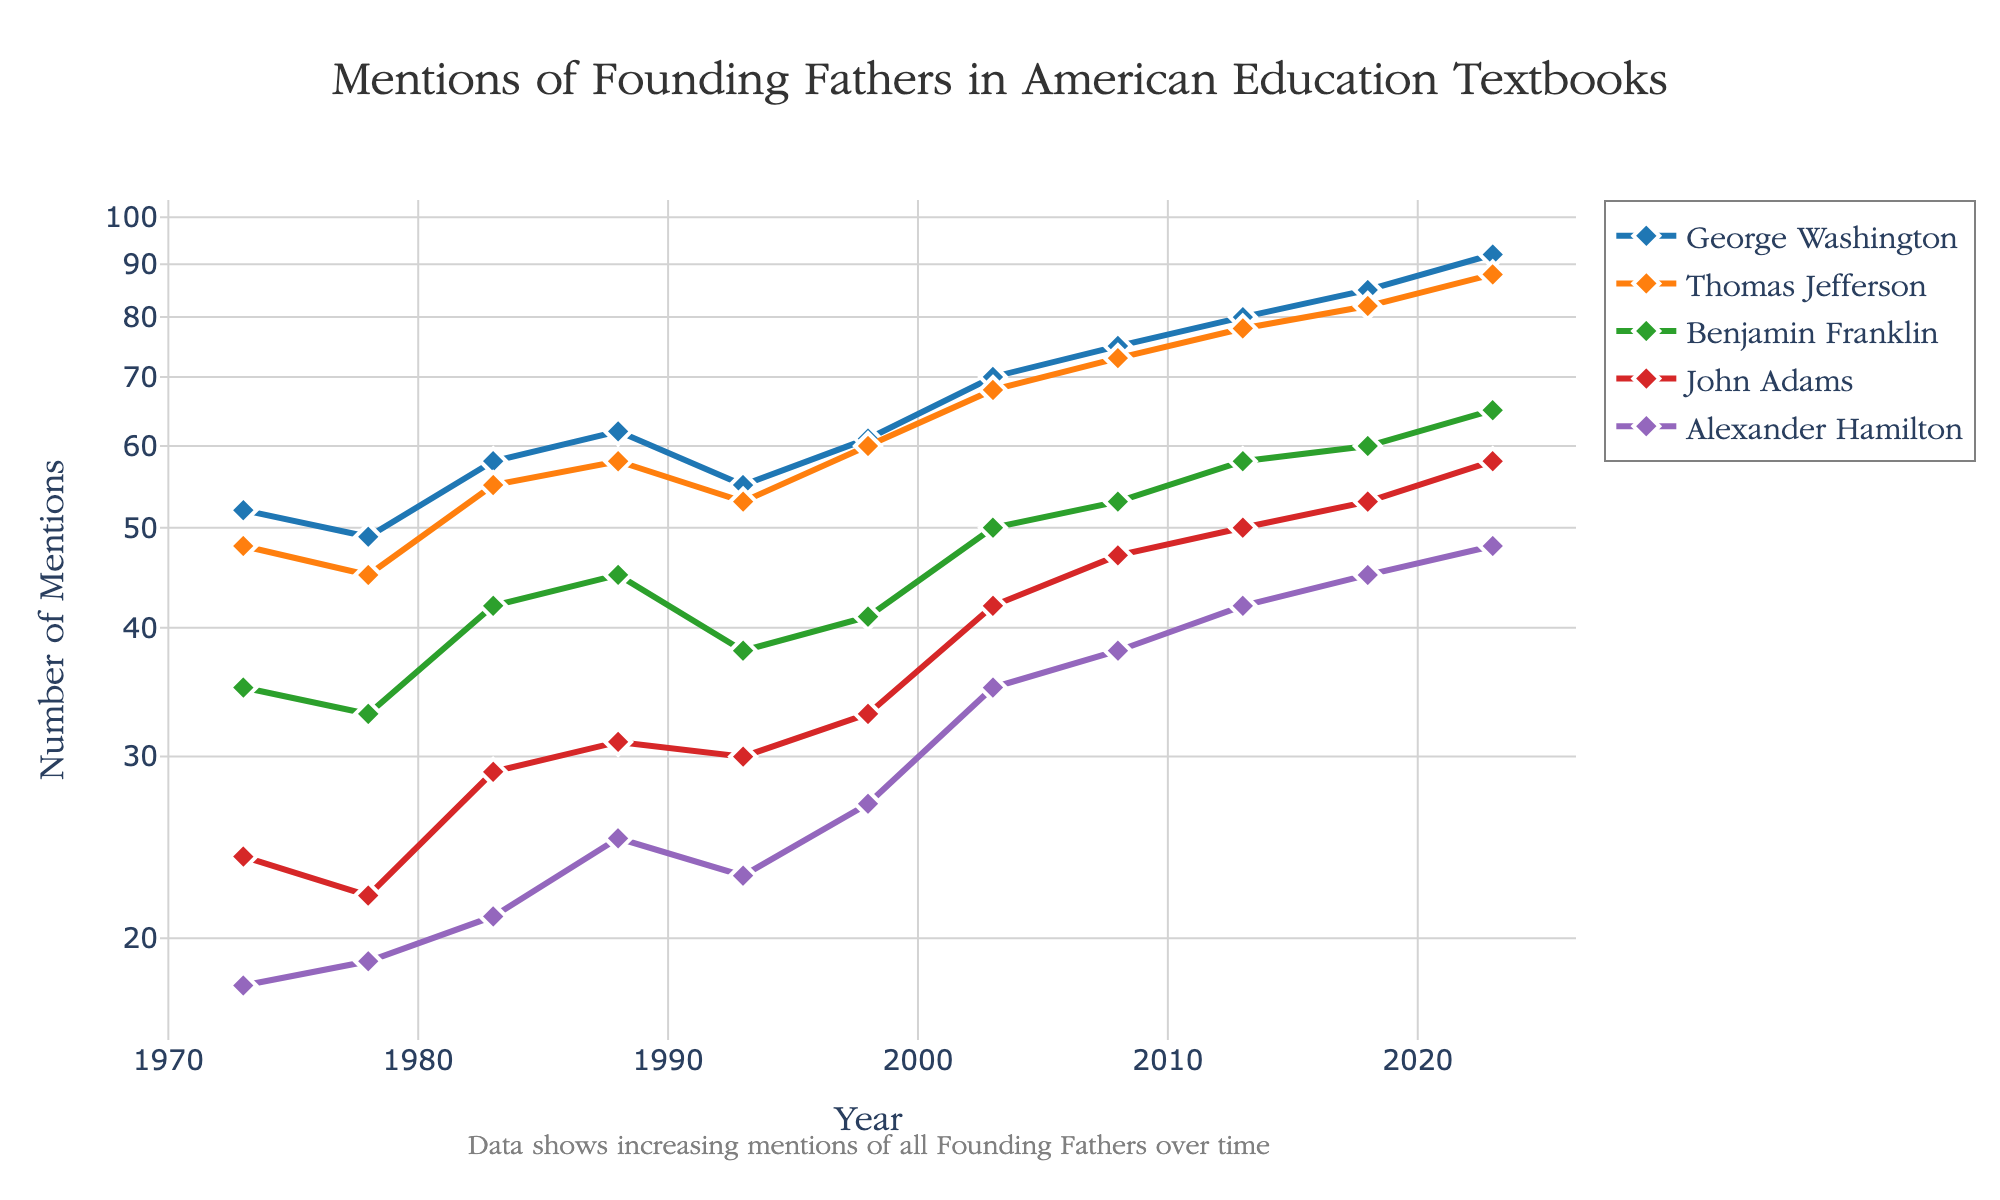What is the title of the figure? The title is located at the top of the figure. It explicitly states what the plot is about.
Answer: Mentions of Founding Fathers in American Education Textbooks Which founding father has the highest number of mentions in 2023? By looking at the y-axis values for the year 2023, you can compare the mention counts.
Answer: George Washington How many years does the plot cover? The x-axis represents years from the beginning to the end data points. Counting all of them gives us the time span.
Answer: 50 years What is the pattern of mentions for Thomas Jefferson from 1973 to 2023? Observing the line corresponding to Thomas Jefferson from left to right (1973 to 2023) on the plot shows a trend.
Answer: Increasing By how much did the mentions of Alexander Hamilton increase from 1973 to 2023? Subtract the y-axis value for Alexander Hamilton in 1973 from the value in 2023.
Answer: 30 Which founding father experienced the least fluctuation in mentions? By comparing the range of values for each founding father over the years, you can determine which one has the smallest range.
Answer: Alexander Hamilton In which year did John Adams receive the highest number of mentions? Look for the peak value of John Adams' line trace and check the corresponding year on the x-axis.
Answer: 2023 How does the log scale on the y-axis affect the perception of trends in mentions? The log scale compresses the range of values, making exponential increases appear more linear and allowing for easier comparison across wide-ranging data.
Answer: Compresses exponential increases What is the difference in the number of mentions between George Washington and Benjamin Franklin in 1988? Find the difference between the y-axis values for George Washington and Benjamin Franklin in 1988.
Answer: 17 Did mentions of Benjamin Franklin ever surpass 60 in any year? Check the y-axis values along Benjamin Franklin’s trace to see if it ever crosses 60.
Answer: No 